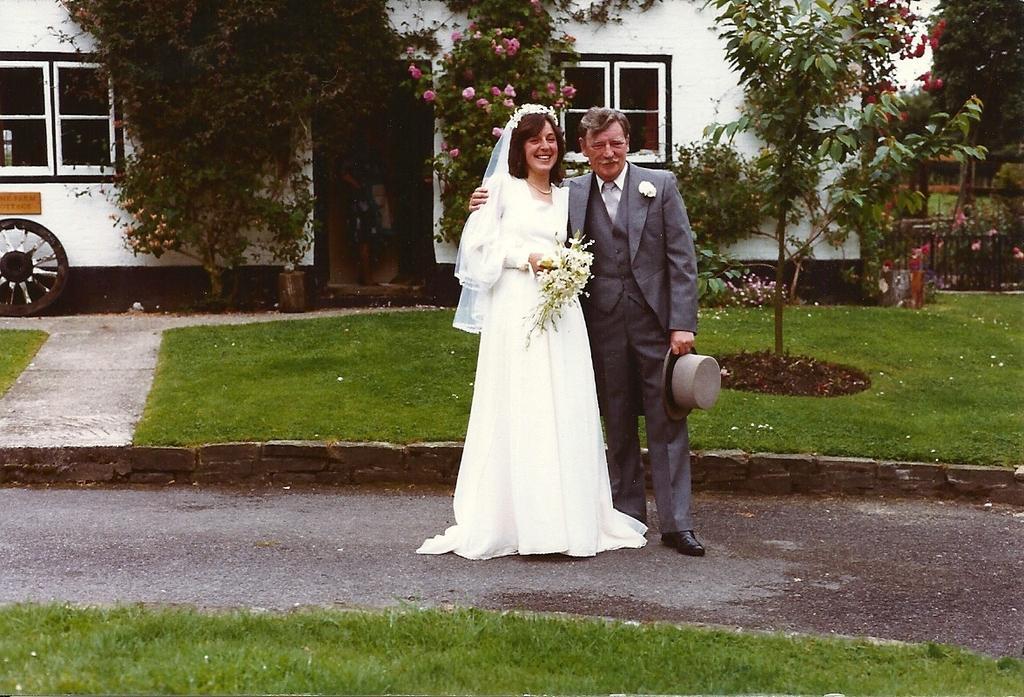How would you summarize this image in a sentence or two? This picture is clicked outside. In the foreground we can see the green grass. In the center there is a man wearing suit, holding a hat, smiling and standing on the ground and there is a woman wearing white color dress, holding flowers and standing on the ground. In the background we can see a vehicle and the windows of the vehicle and we can see the trees, plants and the grass. 